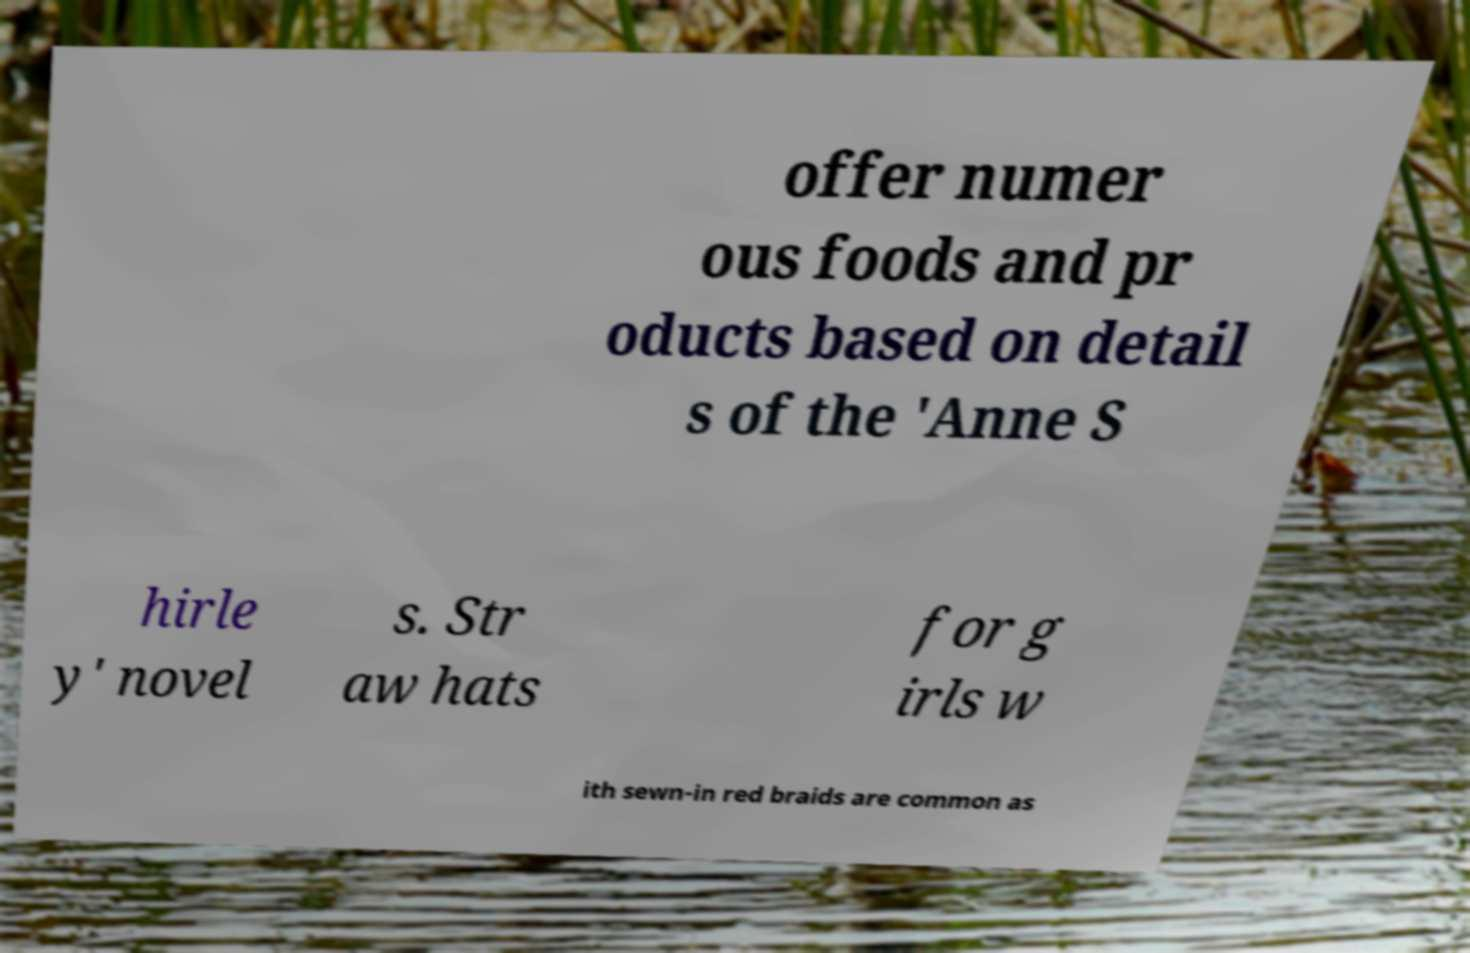Can you accurately transcribe the text from the provided image for me? offer numer ous foods and pr oducts based on detail s of the 'Anne S hirle y' novel s. Str aw hats for g irls w ith sewn-in red braids are common as 